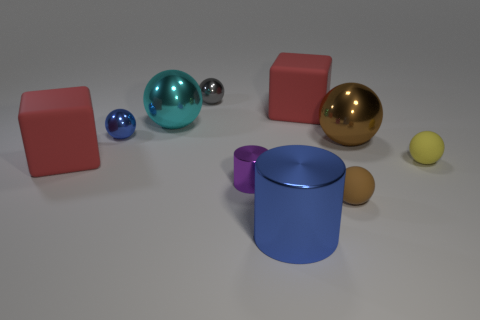Is there a blue object made of the same material as the small purple cylinder?
Keep it short and to the point. Yes. There is a big cyan ball on the right side of the blue metal thing behind the yellow object; is there a large shiny sphere on the right side of it?
Make the answer very short. Yes. There is a cyan metal object that is the same size as the brown shiny thing; what is its shape?
Your answer should be very brief. Sphere. Do the red block in front of the big brown ball and the ball in front of the small yellow matte sphere have the same size?
Make the answer very short. No. What number of blue things are there?
Provide a short and direct response. 2. What is the size of the rubber sphere that is to the left of the matte ball behind the tiny matte object in front of the tiny yellow matte sphere?
Provide a short and direct response. Small. Does the tiny shiny cylinder have the same color as the big metallic cylinder?
Your answer should be compact. No. Is there anything else that is the same size as the gray metallic thing?
Provide a succinct answer. Yes. There is a small gray shiny thing; what number of objects are right of it?
Give a very brief answer. 6. Are there the same number of brown matte balls in front of the large blue object and purple cylinders?
Your answer should be compact. No. 